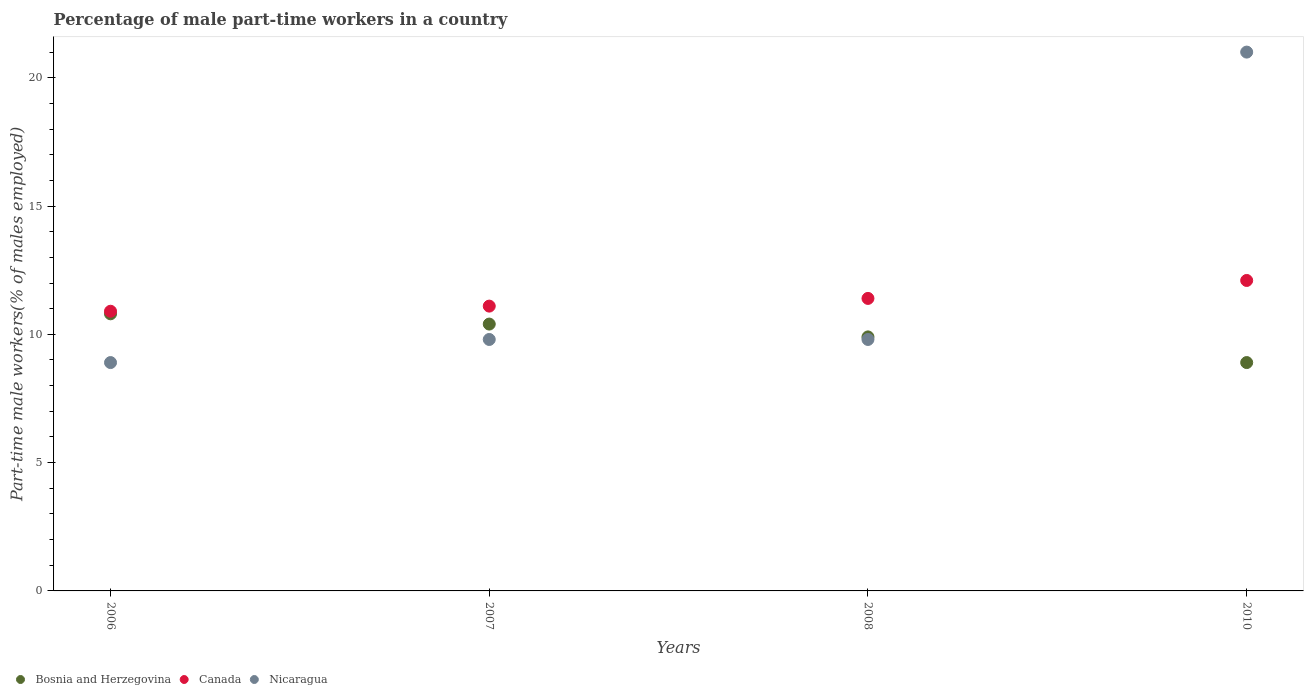How many different coloured dotlines are there?
Your answer should be compact. 3. What is the percentage of male part-time workers in Nicaragua in 2008?
Give a very brief answer. 9.8. Across all years, what is the maximum percentage of male part-time workers in Nicaragua?
Offer a terse response. 21. Across all years, what is the minimum percentage of male part-time workers in Canada?
Keep it short and to the point. 10.9. In which year was the percentage of male part-time workers in Nicaragua maximum?
Offer a very short reply. 2010. What is the total percentage of male part-time workers in Canada in the graph?
Your answer should be very brief. 45.5. What is the difference between the percentage of male part-time workers in Canada in 2007 and that in 2008?
Offer a terse response. -0.3. What is the difference between the percentage of male part-time workers in Bosnia and Herzegovina in 2010 and the percentage of male part-time workers in Nicaragua in 2008?
Keep it short and to the point. -0.9. What is the average percentage of male part-time workers in Canada per year?
Your answer should be compact. 11.38. In the year 2007, what is the difference between the percentage of male part-time workers in Bosnia and Herzegovina and percentage of male part-time workers in Canada?
Offer a terse response. -0.7. In how many years, is the percentage of male part-time workers in Bosnia and Herzegovina greater than 12 %?
Provide a short and direct response. 0. What is the ratio of the percentage of male part-time workers in Bosnia and Herzegovina in 2006 to that in 2008?
Keep it short and to the point. 1.09. Is the difference between the percentage of male part-time workers in Bosnia and Herzegovina in 2006 and 2010 greater than the difference between the percentage of male part-time workers in Canada in 2006 and 2010?
Your answer should be very brief. Yes. What is the difference between the highest and the second highest percentage of male part-time workers in Bosnia and Herzegovina?
Give a very brief answer. 0.4. What is the difference between the highest and the lowest percentage of male part-time workers in Canada?
Give a very brief answer. 1.2. In how many years, is the percentage of male part-time workers in Bosnia and Herzegovina greater than the average percentage of male part-time workers in Bosnia and Herzegovina taken over all years?
Offer a very short reply. 2. Is the sum of the percentage of male part-time workers in Bosnia and Herzegovina in 2007 and 2008 greater than the maximum percentage of male part-time workers in Canada across all years?
Provide a succinct answer. Yes. Is it the case that in every year, the sum of the percentage of male part-time workers in Canada and percentage of male part-time workers in Nicaragua  is greater than the percentage of male part-time workers in Bosnia and Herzegovina?
Keep it short and to the point. Yes. Is the percentage of male part-time workers in Nicaragua strictly less than the percentage of male part-time workers in Canada over the years?
Give a very brief answer. No. How many years are there in the graph?
Keep it short and to the point. 4. Are the values on the major ticks of Y-axis written in scientific E-notation?
Your answer should be very brief. No. Does the graph contain any zero values?
Offer a terse response. No. Does the graph contain grids?
Ensure brevity in your answer.  No. Where does the legend appear in the graph?
Your answer should be compact. Bottom left. What is the title of the graph?
Ensure brevity in your answer.  Percentage of male part-time workers in a country. What is the label or title of the X-axis?
Your answer should be compact. Years. What is the label or title of the Y-axis?
Your answer should be very brief. Part-time male workers(% of males employed). What is the Part-time male workers(% of males employed) in Bosnia and Herzegovina in 2006?
Provide a short and direct response. 10.8. What is the Part-time male workers(% of males employed) of Canada in 2006?
Provide a succinct answer. 10.9. What is the Part-time male workers(% of males employed) in Nicaragua in 2006?
Make the answer very short. 8.9. What is the Part-time male workers(% of males employed) of Bosnia and Herzegovina in 2007?
Provide a short and direct response. 10.4. What is the Part-time male workers(% of males employed) in Canada in 2007?
Keep it short and to the point. 11.1. What is the Part-time male workers(% of males employed) in Nicaragua in 2007?
Ensure brevity in your answer.  9.8. What is the Part-time male workers(% of males employed) in Bosnia and Herzegovina in 2008?
Make the answer very short. 9.9. What is the Part-time male workers(% of males employed) of Canada in 2008?
Offer a very short reply. 11.4. What is the Part-time male workers(% of males employed) of Nicaragua in 2008?
Offer a very short reply. 9.8. What is the Part-time male workers(% of males employed) of Bosnia and Herzegovina in 2010?
Provide a succinct answer. 8.9. What is the Part-time male workers(% of males employed) of Canada in 2010?
Your answer should be very brief. 12.1. Across all years, what is the maximum Part-time male workers(% of males employed) of Bosnia and Herzegovina?
Provide a short and direct response. 10.8. Across all years, what is the maximum Part-time male workers(% of males employed) of Canada?
Make the answer very short. 12.1. Across all years, what is the maximum Part-time male workers(% of males employed) of Nicaragua?
Give a very brief answer. 21. Across all years, what is the minimum Part-time male workers(% of males employed) in Bosnia and Herzegovina?
Keep it short and to the point. 8.9. Across all years, what is the minimum Part-time male workers(% of males employed) of Canada?
Ensure brevity in your answer.  10.9. Across all years, what is the minimum Part-time male workers(% of males employed) in Nicaragua?
Your answer should be very brief. 8.9. What is the total Part-time male workers(% of males employed) of Canada in the graph?
Your response must be concise. 45.5. What is the total Part-time male workers(% of males employed) of Nicaragua in the graph?
Ensure brevity in your answer.  49.5. What is the difference between the Part-time male workers(% of males employed) of Bosnia and Herzegovina in 2006 and that in 2007?
Provide a short and direct response. 0.4. What is the difference between the Part-time male workers(% of males employed) of Bosnia and Herzegovina in 2006 and that in 2008?
Offer a very short reply. 0.9. What is the difference between the Part-time male workers(% of males employed) of Canada in 2006 and that in 2010?
Ensure brevity in your answer.  -1.2. What is the difference between the Part-time male workers(% of males employed) of Bosnia and Herzegovina in 2007 and that in 2008?
Your answer should be very brief. 0.5. What is the difference between the Part-time male workers(% of males employed) in Canada in 2007 and that in 2010?
Your response must be concise. -1. What is the difference between the Part-time male workers(% of males employed) of Nicaragua in 2007 and that in 2010?
Your answer should be very brief. -11.2. What is the difference between the Part-time male workers(% of males employed) of Bosnia and Herzegovina in 2006 and the Part-time male workers(% of males employed) of Canada in 2007?
Ensure brevity in your answer.  -0.3. What is the difference between the Part-time male workers(% of males employed) of Bosnia and Herzegovina in 2006 and the Part-time male workers(% of males employed) of Nicaragua in 2008?
Provide a succinct answer. 1. What is the difference between the Part-time male workers(% of males employed) of Canada in 2006 and the Part-time male workers(% of males employed) of Nicaragua in 2008?
Keep it short and to the point. 1.1. What is the difference between the Part-time male workers(% of males employed) of Bosnia and Herzegovina in 2006 and the Part-time male workers(% of males employed) of Nicaragua in 2010?
Offer a terse response. -10.2. What is the difference between the Part-time male workers(% of males employed) in Canada in 2006 and the Part-time male workers(% of males employed) in Nicaragua in 2010?
Your answer should be very brief. -10.1. What is the difference between the Part-time male workers(% of males employed) in Bosnia and Herzegovina in 2007 and the Part-time male workers(% of males employed) in Nicaragua in 2008?
Offer a terse response. 0.6. What is the difference between the Part-time male workers(% of males employed) in Bosnia and Herzegovina in 2007 and the Part-time male workers(% of males employed) in Nicaragua in 2010?
Your answer should be compact. -10.6. What is the difference between the Part-time male workers(% of males employed) in Canada in 2007 and the Part-time male workers(% of males employed) in Nicaragua in 2010?
Ensure brevity in your answer.  -9.9. What is the difference between the Part-time male workers(% of males employed) of Bosnia and Herzegovina in 2008 and the Part-time male workers(% of males employed) of Nicaragua in 2010?
Keep it short and to the point. -11.1. What is the average Part-time male workers(% of males employed) of Bosnia and Herzegovina per year?
Make the answer very short. 10. What is the average Part-time male workers(% of males employed) of Canada per year?
Offer a very short reply. 11.38. What is the average Part-time male workers(% of males employed) in Nicaragua per year?
Keep it short and to the point. 12.38. In the year 2006, what is the difference between the Part-time male workers(% of males employed) of Bosnia and Herzegovina and Part-time male workers(% of males employed) of Nicaragua?
Provide a short and direct response. 1.9. In the year 2006, what is the difference between the Part-time male workers(% of males employed) of Canada and Part-time male workers(% of males employed) of Nicaragua?
Ensure brevity in your answer.  2. In the year 2007, what is the difference between the Part-time male workers(% of males employed) in Bosnia and Herzegovina and Part-time male workers(% of males employed) in Canada?
Your answer should be compact. -0.7. In the year 2007, what is the difference between the Part-time male workers(% of males employed) of Canada and Part-time male workers(% of males employed) of Nicaragua?
Your response must be concise. 1.3. In the year 2008, what is the difference between the Part-time male workers(% of males employed) of Bosnia and Herzegovina and Part-time male workers(% of males employed) of Canada?
Your response must be concise. -1.5. In the year 2008, what is the difference between the Part-time male workers(% of males employed) of Bosnia and Herzegovina and Part-time male workers(% of males employed) of Nicaragua?
Provide a short and direct response. 0.1. In the year 2010, what is the difference between the Part-time male workers(% of males employed) in Bosnia and Herzegovina and Part-time male workers(% of males employed) in Nicaragua?
Your answer should be compact. -12.1. What is the ratio of the Part-time male workers(% of males employed) in Bosnia and Herzegovina in 2006 to that in 2007?
Provide a short and direct response. 1.04. What is the ratio of the Part-time male workers(% of males employed) of Canada in 2006 to that in 2007?
Keep it short and to the point. 0.98. What is the ratio of the Part-time male workers(% of males employed) of Nicaragua in 2006 to that in 2007?
Give a very brief answer. 0.91. What is the ratio of the Part-time male workers(% of males employed) in Bosnia and Herzegovina in 2006 to that in 2008?
Your answer should be very brief. 1.09. What is the ratio of the Part-time male workers(% of males employed) of Canada in 2006 to that in 2008?
Ensure brevity in your answer.  0.96. What is the ratio of the Part-time male workers(% of males employed) in Nicaragua in 2006 to that in 2008?
Provide a short and direct response. 0.91. What is the ratio of the Part-time male workers(% of males employed) of Bosnia and Herzegovina in 2006 to that in 2010?
Offer a very short reply. 1.21. What is the ratio of the Part-time male workers(% of males employed) of Canada in 2006 to that in 2010?
Make the answer very short. 0.9. What is the ratio of the Part-time male workers(% of males employed) of Nicaragua in 2006 to that in 2010?
Offer a very short reply. 0.42. What is the ratio of the Part-time male workers(% of males employed) in Bosnia and Herzegovina in 2007 to that in 2008?
Your response must be concise. 1.05. What is the ratio of the Part-time male workers(% of males employed) of Canada in 2007 to that in 2008?
Make the answer very short. 0.97. What is the ratio of the Part-time male workers(% of males employed) in Nicaragua in 2007 to that in 2008?
Your response must be concise. 1. What is the ratio of the Part-time male workers(% of males employed) in Bosnia and Herzegovina in 2007 to that in 2010?
Keep it short and to the point. 1.17. What is the ratio of the Part-time male workers(% of males employed) of Canada in 2007 to that in 2010?
Keep it short and to the point. 0.92. What is the ratio of the Part-time male workers(% of males employed) of Nicaragua in 2007 to that in 2010?
Provide a succinct answer. 0.47. What is the ratio of the Part-time male workers(% of males employed) in Bosnia and Herzegovina in 2008 to that in 2010?
Keep it short and to the point. 1.11. What is the ratio of the Part-time male workers(% of males employed) of Canada in 2008 to that in 2010?
Provide a short and direct response. 0.94. What is the ratio of the Part-time male workers(% of males employed) of Nicaragua in 2008 to that in 2010?
Provide a succinct answer. 0.47. What is the difference between the highest and the second highest Part-time male workers(% of males employed) of Bosnia and Herzegovina?
Offer a terse response. 0.4. What is the difference between the highest and the second highest Part-time male workers(% of males employed) of Canada?
Ensure brevity in your answer.  0.7. What is the difference between the highest and the second highest Part-time male workers(% of males employed) of Nicaragua?
Your answer should be compact. 11.2. What is the difference between the highest and the lowest Part-time male workers(% of males employed) of Nicaragua?
Provide a short and direct response. 12.1. 